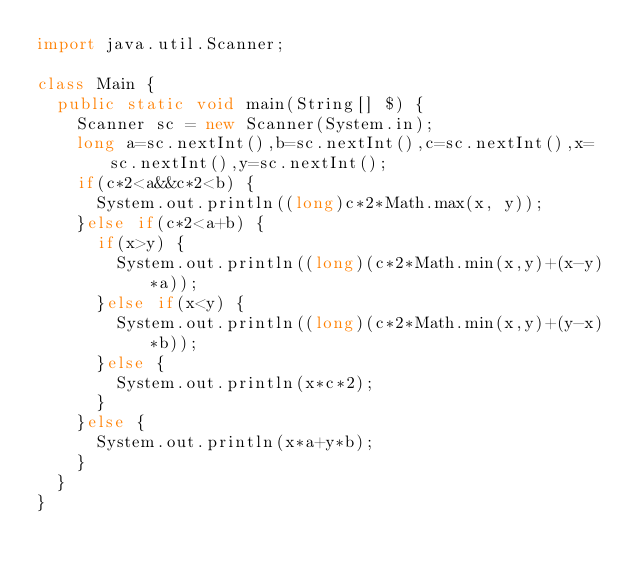<code> <loc_0><loc_0><loc_500><loc_500><_Java_>import java.util.Scanner;

class Main {
	public static void main(String[] $) {
		Scanner sc = new Scanner(System.in);
		long a=sc.nextInt(),b=sc.nextInt(),c=sc.nextInt(),x=sc.nextInt(),y=sc.nextInt();
		if(c*2<a&&c*2<b) {
			System.out.println((long)c*2*Math.max(x, y));
		}else if(c*2<a+b) {
			if(x>y) {
				System.out.println((long)(c*2*Math.min(x,y)+(x-y)*a));
			}else if(x<y) {
				System.out.println((long)(c*2*Math.min(x,y)+(y-x)*b));
			}else {
				System.out.println(x*c*2);
			}
		}else {
			System.out.println(x*a+y*b);
		}
	}
}

</code> 